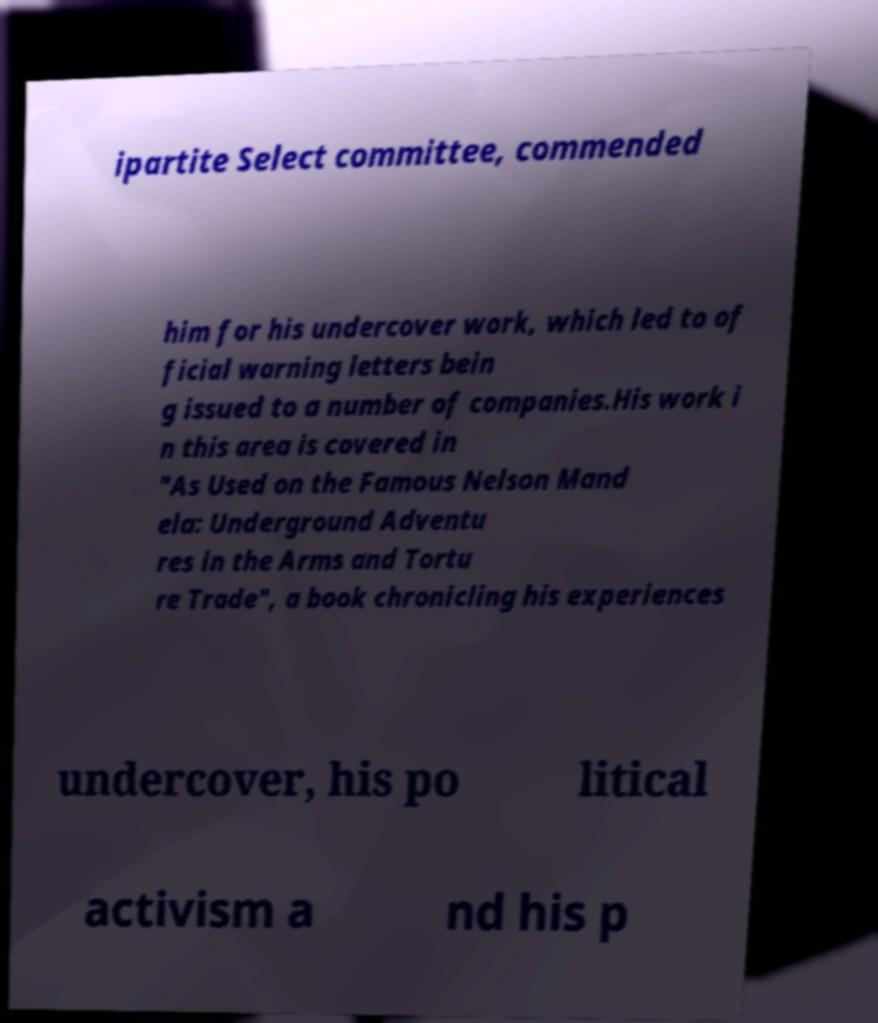Could you assist in decoding the text presented in this image and type it out clearly? ipartite Select committee, commended him for his undercover work, which led to of ficial warning letters bein g issued to a number of companies.His work i n this area is covered in "As Used on the Famous Nelson Mand ela: Underground Adventu res in the Arms and Tortu re Trade", a book chronicling his experiences undercover, his po litical activism a nd his p 